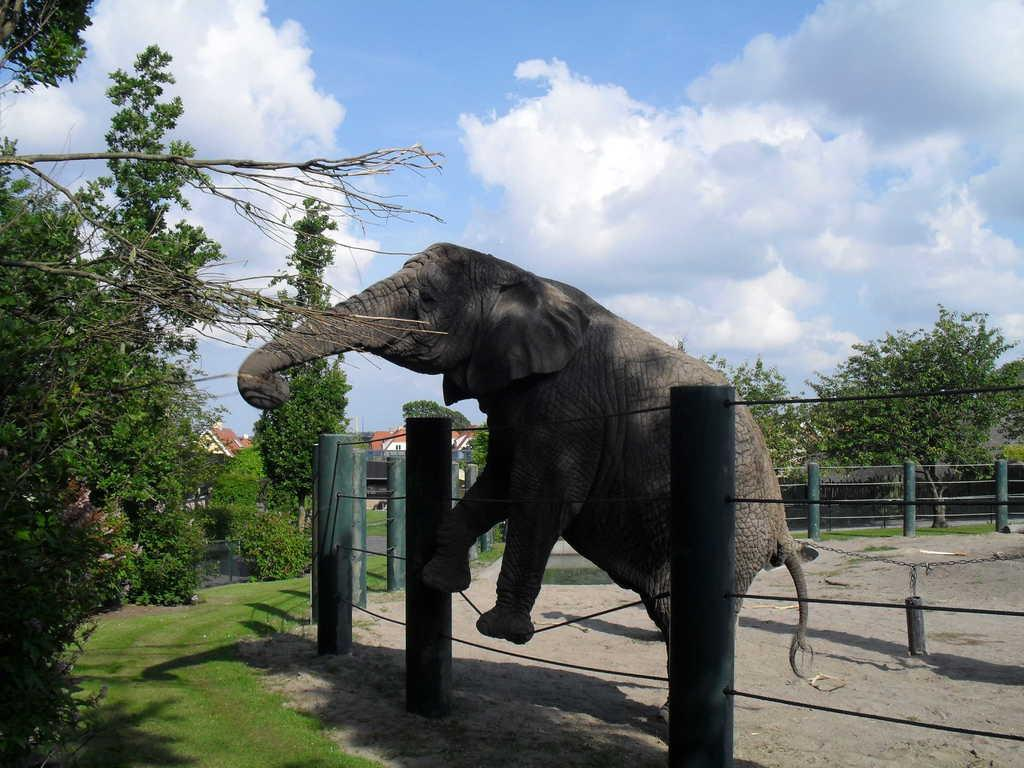What animal is the main subject of the image? There is an elephant in the image. What is the elephant doing in the image? The elephant is trying to eat tree leaves. What is in the front of the image? There is a fencing grill in the front of the image. What can be seen in the background of the image? There are trees in the background of the image. What type of glove is the elephant wearing on its trunk in the image? There is no glove present on the elephant's trunk in the image. 